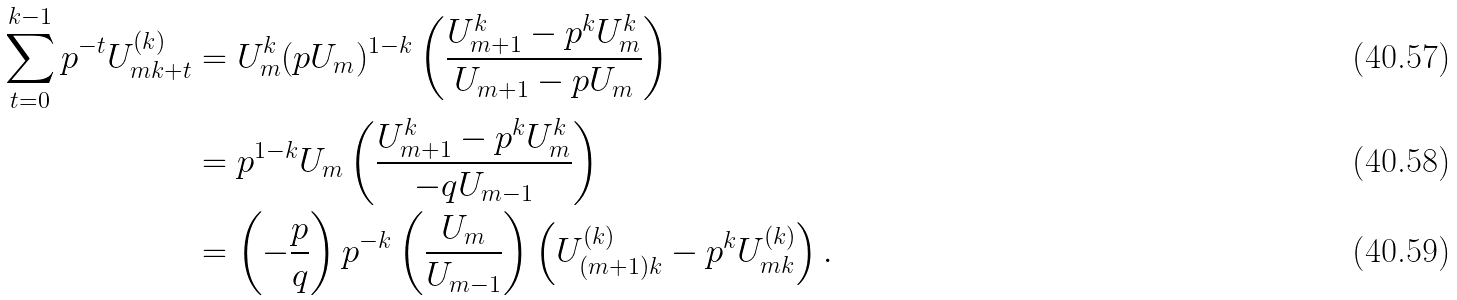Convert formula to latex. <formula><loc_0><loc_0><loc_500><loc_500>\sum _ { t = 0 } ^ { k - 1 } p ^ { - t } U _ { m k + t } ^ { ( k ) } & = U _ { m } ^ { k } ( p U _ { m } ) ^ { 1 - k } \left ( \frac { U _ { m + 1 } ^ { k } - p ^ { k } U _ { m } ^ { k } } { U _ { m + 1 } - p U _ { m } } \right ) \\ & = p ^ { 1 - k } U _ { m } \left ( \frac { U _ { m + 1 } ^ { k } - p ^ { k } U _ { m } ^ { k } } { - q U _ { m - 1 } } \right ) \\ & = \left ( - \frac { p } { q } \right ) p ^ { - k } \left ( \frac { U _ { m } } { U _ { m - 1 } } \right ) \left ( U _ { ( m + 1 ) k } ^ { ( k ) } - p ^ { k } U _ { m k } ^ { ( k ) } \right ) .</formula> 